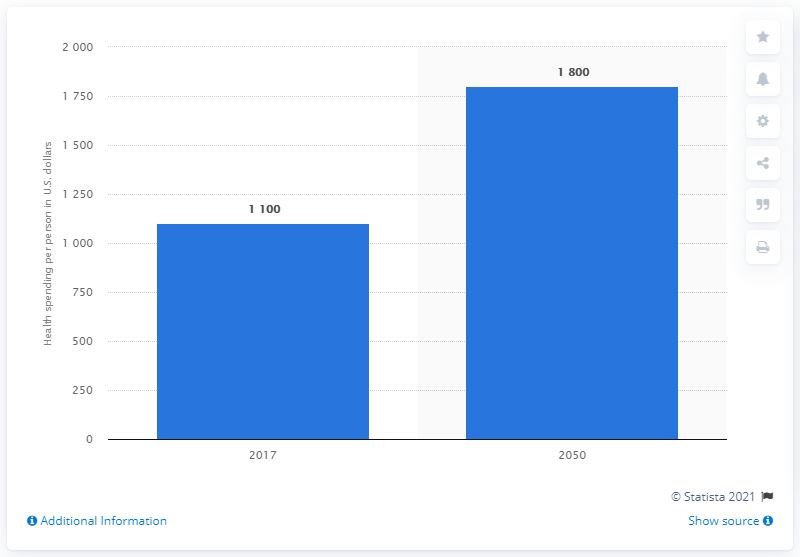Give some essential details in this illustration. According to projections, global health spending per person is expected to reach 1,800 U.S. dollars in 2050. 